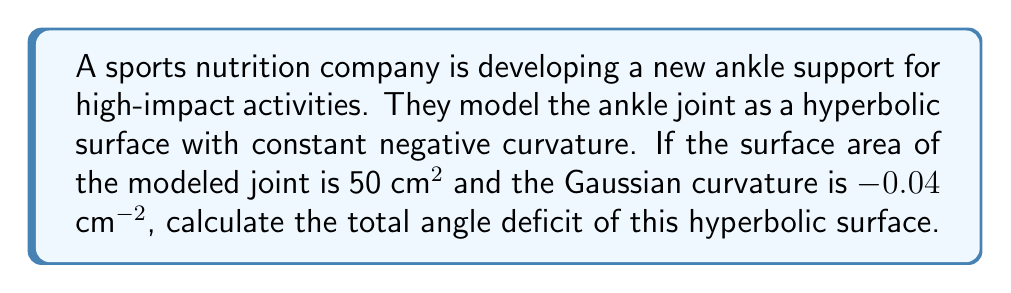Help me with this question. To solve this problem, we'll use the Gauss-Bonnet theorem for hyperbolic surfaces. The steps are as follows:

1) The Gauss-Bonnet theorem states that for a compact surface $M$ with Gaussian curvature $K$:

   $$\int_M K dA + \sum_{i=1}^n \theta_i = 2\pi\chi(M)$$

   where $\theta_i$ are the exterior angles of the boundary, and $\chi(M)$ is the Euler characteristic.

2) For our ankle joint model, we assume a closed surface without boundary, so $\sum_{i=1}^n \theta_i = 0$.

3) The Euler characteristic for a closed surface topologically equivalent to a sphere (which we assume for the ankle joint) is $\chi(M) = 2$.

4) The Gaussian curvature $K$ is constant at -0.04 cm⁻², and the surface area $A$ is 50 cm².

5) Substituting these values into the Gauss-Bonnet theorem:

   $$(-0.04 \text{ cm}^{-2})(50 \text{ cm}^2) = 2\pi(2) - \text{Angle Deficit}$$

6) Simplifying:

   $$-2 = 4\pi - \text{Angle Deficit}$$

7) Solving for the Angle Deficit:

   $$\text{Angle Deficit} = 4\pi + 2 = 4\pi + 2 \approx 14.57 \text{ radians}$$

This angle deficit represents the total "missing" angle when compared to a flat Euclidean surface, indicating the degree of hyperbolic curvature in the joint model.
Answer: $4\pi + 2$ radians (≈ 14.57 radians) 